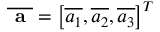<formula> <loc_0><loc_0><loc_500><loc_500>\overline { a } = \left [ \overline { { a _ { 1 } } } , \overline { { a _ { 2 } } } , \overline { { a _ { 3 } } } \right ] ^ { T }</formula> 